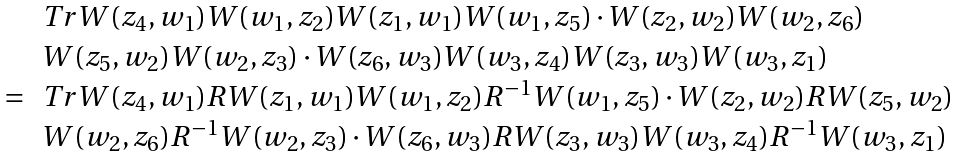<formula> <loc_0><loc_0><loc_500><loc_500>\begin{array} { r l } & T r W ( z _ { 4 } , w _ { 1 } ) W ( w _ { 1 } , z _ { 2 } ) W ( z _ { 1 } , w _ { 1 } ) W ( w _ { 1 } , z _ { 5 } ) \cdot W ( z _ { 2 } , w _ { 2 } ) W ( w _ { 2 } , z _ { 6 } ) \\ & W ( z _ { 5 } , w _ { 2 } ) W ( w _ { 2 } , z _ { 3 } ) \cdot W ( z _ { 6 } , w _ { 3 } ) W ( w _ { 3 } , z _ { 4 } ) W ( z _ { 3 } , w _ { 3 } ) W ( w _ { 3 } , z _ { 1 } ) \\ = & T r W ( z _ { 4 } , w _ { 1 } ) R W ( z _ { 1 } , w _ { 1 } ) W ( w _ { 1 } , z _ { 2 } ) R ^ { - 1 } W ( w _ { 1 } , z _ { 5 } ) \cdot W ( z _ { 2 } , w _ { 2 } ) R W ( z _ { 5 } , w _ { 2 } ) \\ & W ( w _ { 2 } , z _ { 6 } ) R ^ { - 1 } W ( w _ { 2 } , z _ { 3 } ) \cdot W ( z _ { 6 } , w _ { 3 } ) R W ( z _ { 3 } , w _ { 3 } ) W ( w _ { 3 } , z _ { 4 } ) R ^ { - 1 } W ( w _ { 3 } , z _ { 1 } ) \\ \end{array}</formula> 